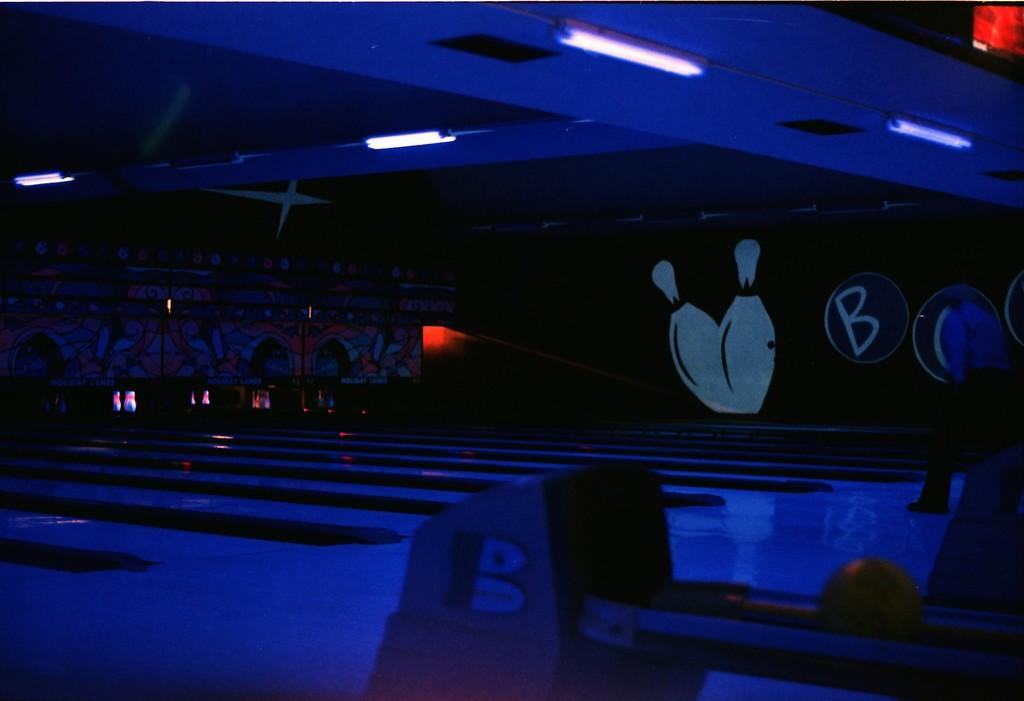What type of lighting is present in the image? There are lights on the ceiling in the image. What decorative items can be seen on the wall in the image? There are paintings on the wall in the image. What is on the floor in the image? There are objects on the floor in the image. How would you describe the lighting in the image? The image is described as being a little bit dark. What type of silk material is draped over the furniture in the image? There is no silk material present in the image. What type of ray can be seen emitting from the paintings in the image? There are no rays emitting from the paintings in the image. 